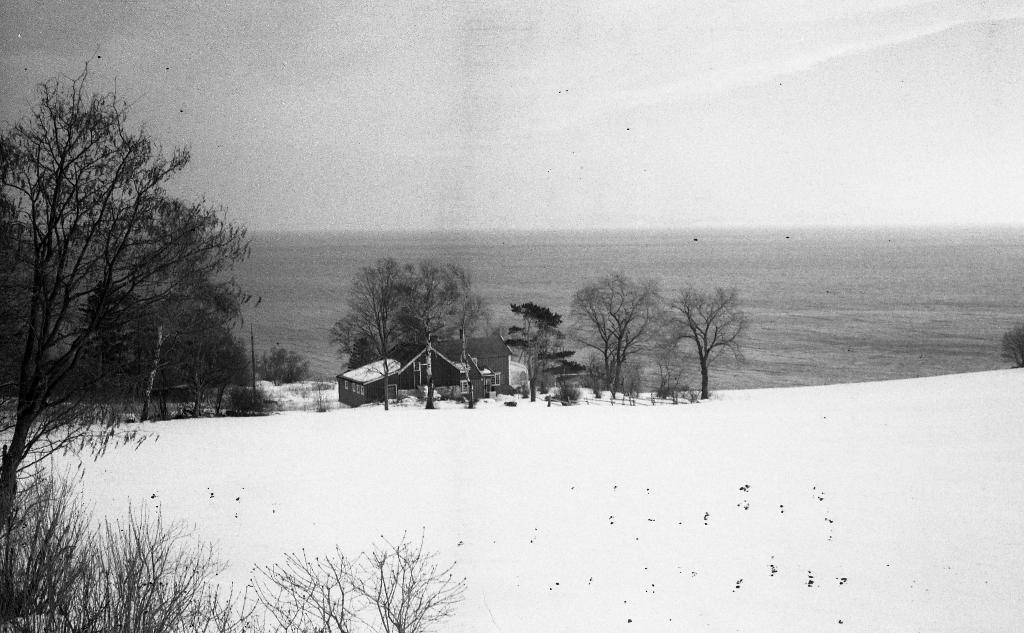Can you describe this image briefly? This is a black and white image. We can see a house. There are a few trees, plants. We can see the ground covered with snow. We can also see a pole and the sky. We can see some water. 